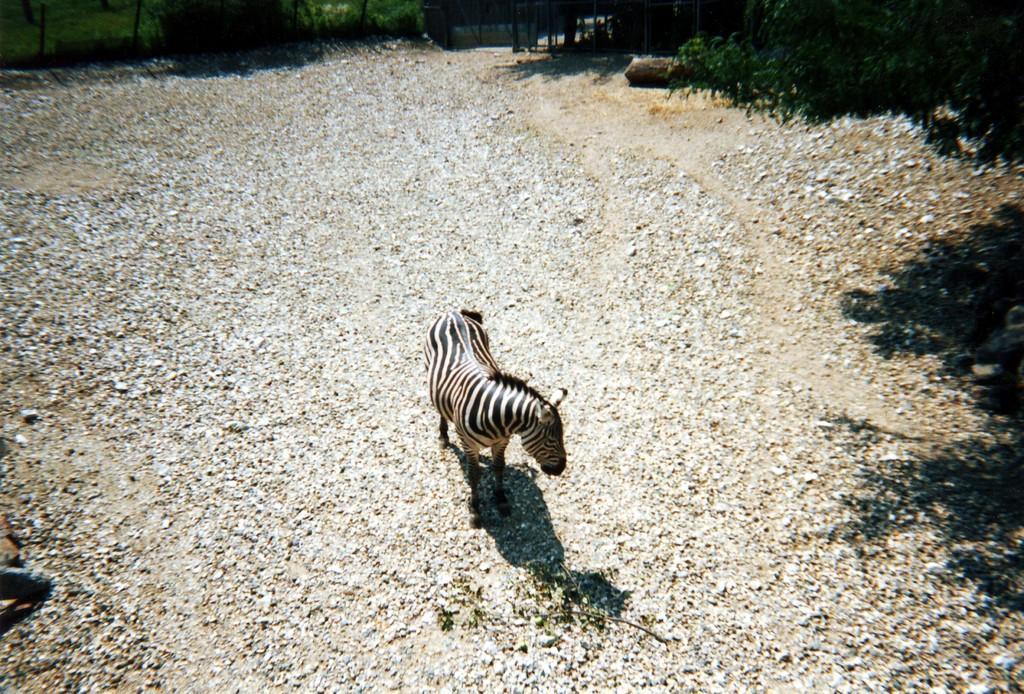Can you describe this image briefly? In the picture we can see a path filled with stone on it, we can see a zebra standing and around the path we can see plants and wall. 